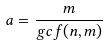Convert formula to latex. <formula><loc_0><loc_0><loc_500><loc_500>a = \frac { m } { g c f ( n , m ) }</formula> 